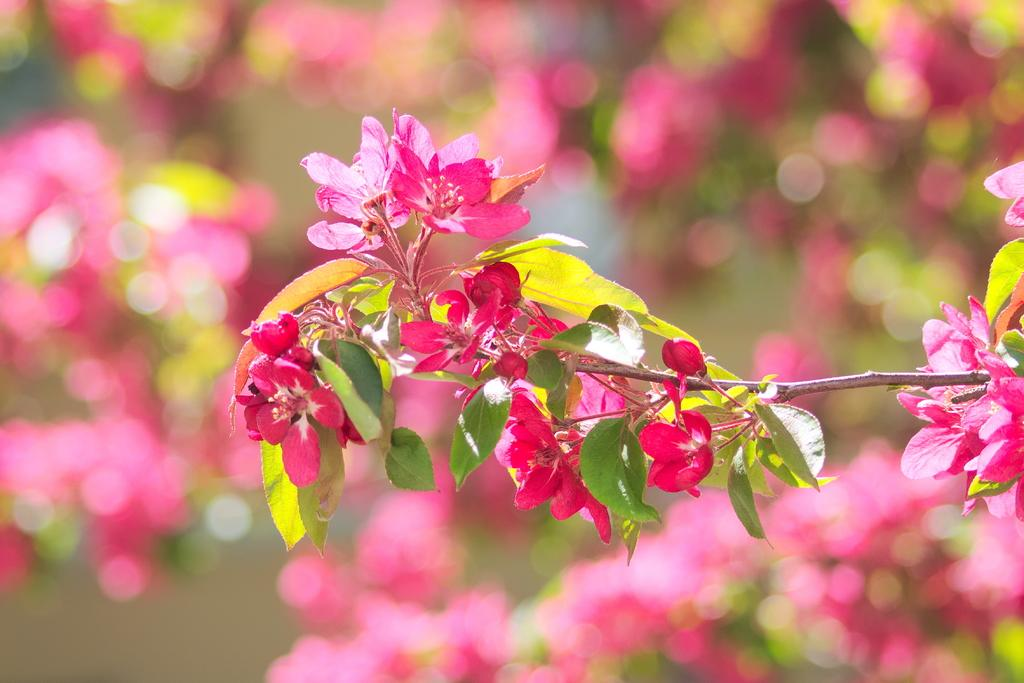What is the main subject in the image? There is a tree in the image. What specific feature can be observed on the tree? The tree has flowers. How would you describe the background of the image? The background of the image is blurred. What type of crayon is being used to draw on the tree in the image? There is no crayon or drawing present on the tree in the image. What impulse might have led someone to create the image? It is not possible to determine the impulse or motivation behind the creation of the image based on the provided facts. 